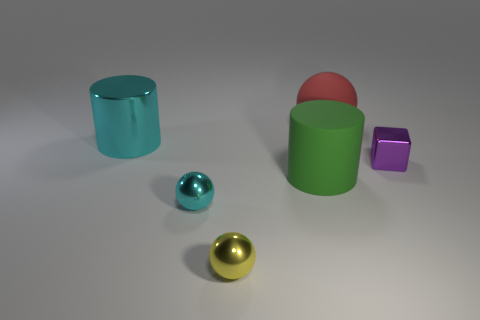Is the number of cyan metallic things behind the block less than the number of big green metal things?
Offer a terse response. No. What is the color of the big thing that is both on the right side of the metallic cylinder and on the left side of the big red object?
Provide a short and direct response. Green. What number of other objects are there of the same shape as the small yellow object?
Offer a very short reply. 2. Is the number of large green matte objects that are on the left side of the cyan sphere less than the number of purple cubes that are behind the large cyan object?
Keep it short and to the point. No. Is the material of the big red sphere the same as the tiny ball behind the small yellow thing?
Keep it short and to the point. No. Is there any other thing that has the same material as the red thing?
Give a very brief answer. Yes. Is the number of big purple blocks greater than the number of big metallic things?
Offer a terse response. No. What shape is the tiny metallic object that is right of the small metal object that is in front of the cyan metallic object right of the big metal thing?
Ensure brevity in your answer.  Cube. Are the small object that is right of the red rubber sphere and the large cylinder that is in front of the cyan shiny cylinder made of the same material?
Provide a succinct answer. No. What is the shape of the other thing that is made of the same material as the large red thing?
Offer a very short reply. Cylinder. 